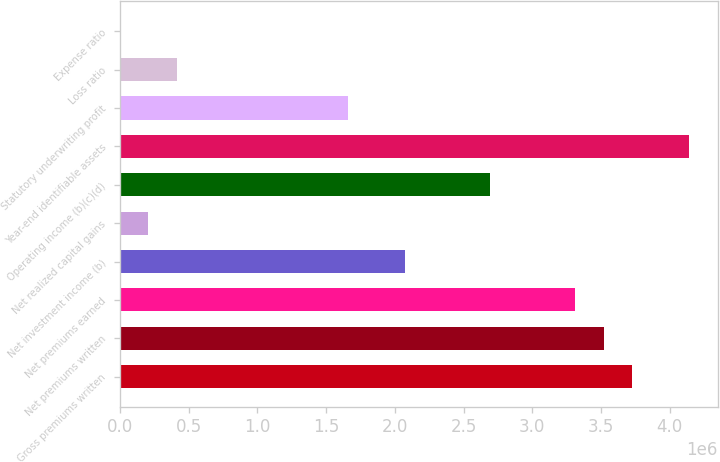Convert chart to OTSL. <chart><loc_0><loc_0><loc_500><loc_500><bar_chart><fcel>Gross premiums written<fcel>Net premiums written<fcel>Net premiums earned<fcel>Net investment income (b)<fcel>Net realized capital gains<fcel>Operating income (b)(c)(d)<fcel>Year-end identifiable assets<fcel>Statutory underwriting profit<fcel>Loss ratio<fcel>Expense ratio<nl><fcel>3.72706e+06<fcel>3.52e+06<fcel>3.31295e+06<fcel>2.0706e+06<fcel>207082<fcel>2.69177e+06<fcel>4.14118e+06<fcel>1.65648e+06<fcel>414140<fcel>24.5<nl></chart> 